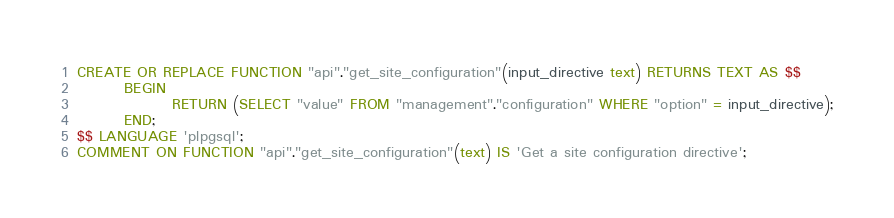<code> <loc_0><loc_0><loc_500><loc_500><_SQL_>
CREATE OR REPLACE FUNCTION "api"."get_site_configuration"(input_directive text) RETURNS TEXT AS $$
        BEGIN
                RETURN (SELECT "value" FROM "management"."configuration" WHERE "option" = input_directive);
        END;
$$ LANGUAGE 'plpgsql';
COMMENT ON FUNCTION "api"."get_site_configuration"(text) IS 'Get a site configuration directive';</code> 